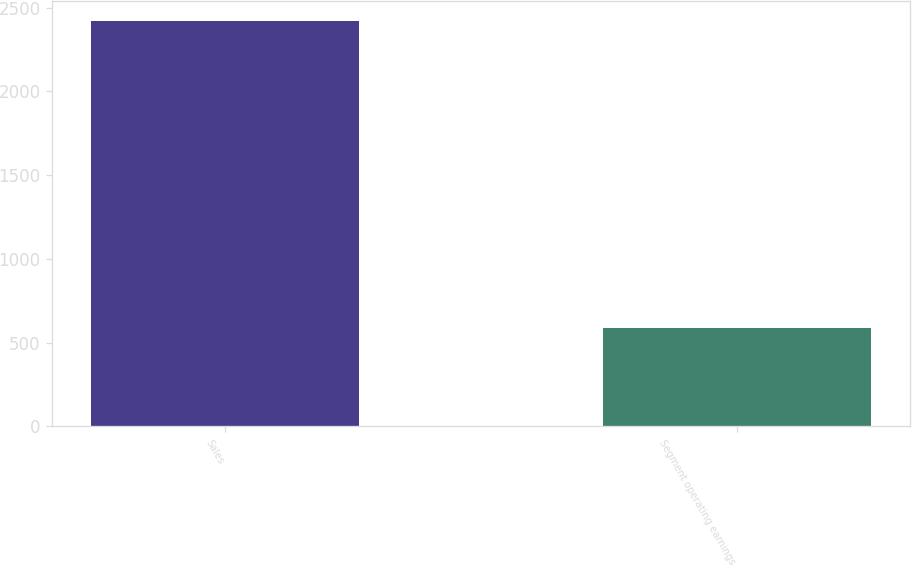Convert chart. <chart><loc_0><loc_0><loc_500><loc_500><bar_chart><fcel>Sales<fcel>Segment operating earnings<nl><fcel>2419.7<fcel>584.7<nl></chart> 